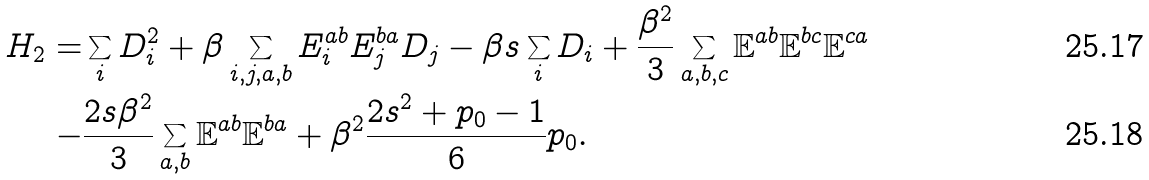Convert formula to latex. <formula><loc_0><loc_0><loc_500><loc_500>H _ { 2 } = & \sum _ { i } D _ { i } ^ { 2 } + \beta \sum _ { i , j , a , b } E ^ { a b } _ { i } E ^ { b a } _ { j } D _ { j } - \beta s \sum _ { i } D _ { i } + \frac { \beta ^ { 2 } } { 3 } \sum _ { a , b , c } \mathbb { E } ^ { a b } \mathbb { E } ^ { b c } \mathbb { E } ^ { c a } \\ - & \frac { 2 s \beta ^ { 2 } } { 3 } \sum _ { a , b } \mathbb { E } ^ { a b } \mathbb { E } ^ { b a } + \beta ^ { 2 } \frac { 2 s ^ { 2 } + p _ { 0 } - 1 } { 6 } p _ { 0 } .</formula> 